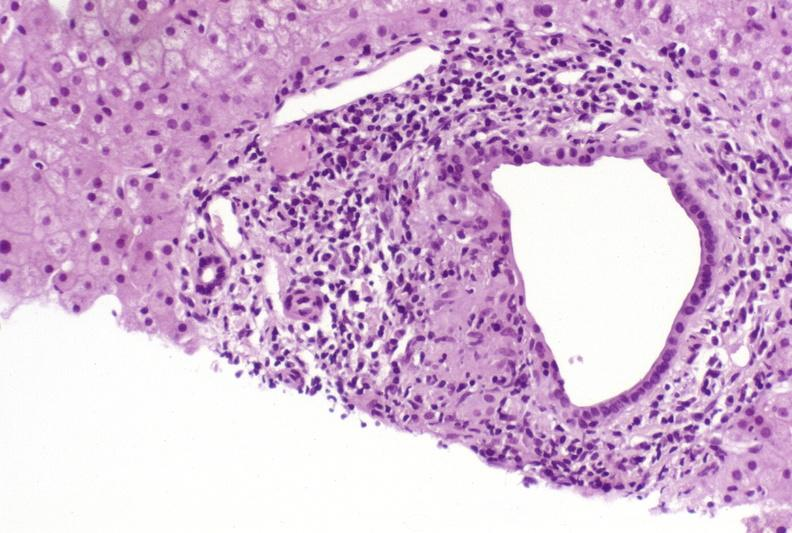s hepatobiliary present?
Answer the question using a single word or phrase. Yes 